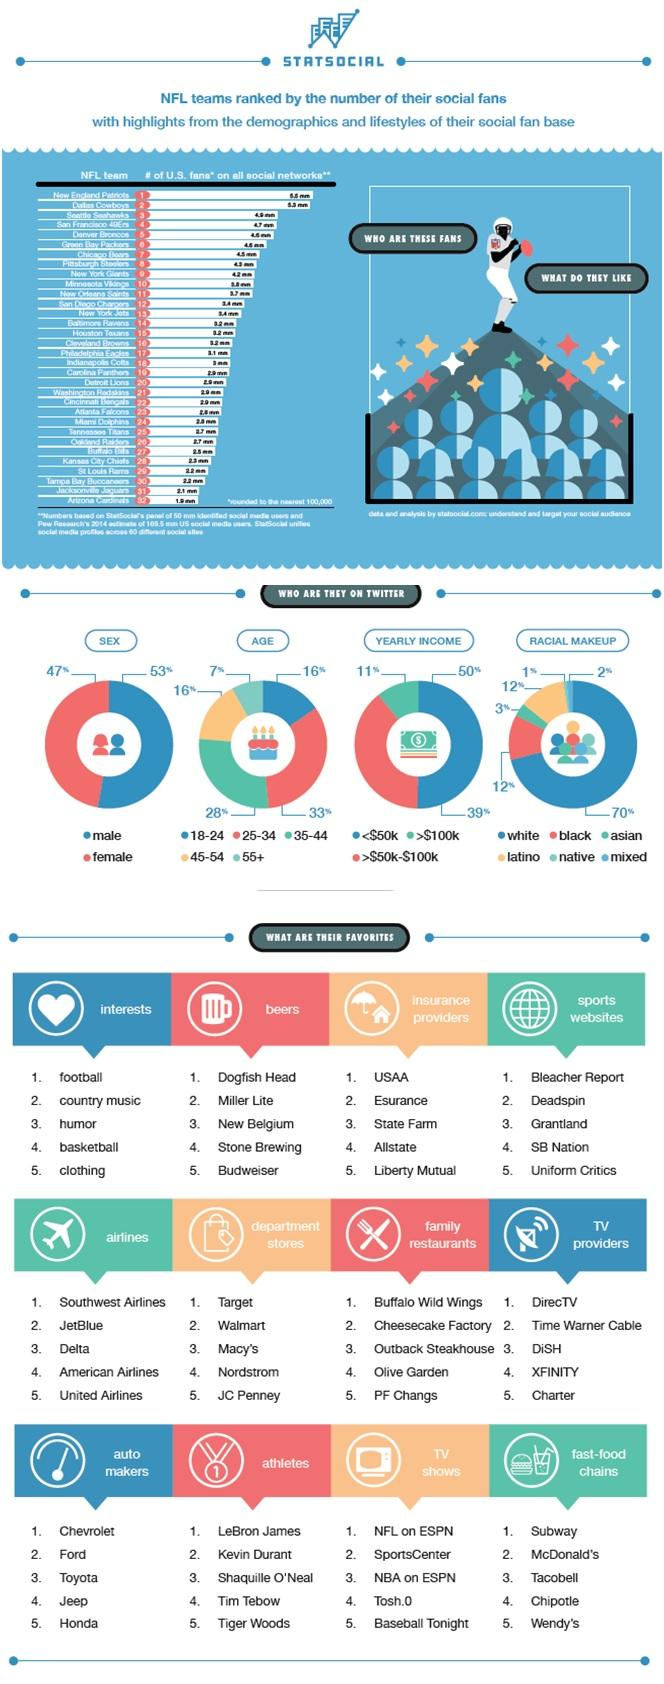Specify some key components in this picture. The age group of 55 and older is the least active among NFL fan followers on Twitter in the United States. According to a recent survey, 70% of NFL fans on Twitter in the United States are white. According to a survey, Subway is the most preferred fast-food chain among NFL fans in the United States. According to a recent survey, 53% of NFL fans on Twitter in the United States are male. According to a recent survey, Bleacher Report is the most popular sports website among NFL fans in the United States. 